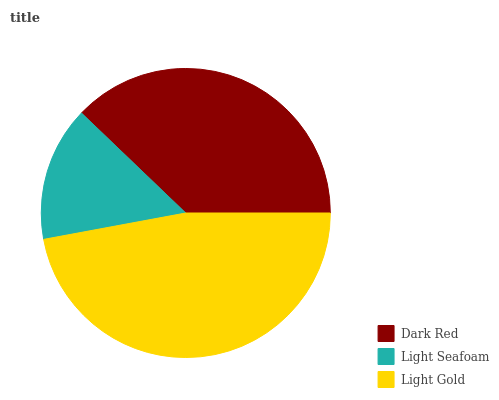Is Light Seafoam the minimum?
Answer yes or no. Yes. Is Light Gold the maximum?
Answer yes or no. Yes. Is Light Gold the minimum?
Answer yes or no. No. Is Light Seafoam the maximum?
Answer yes or no. No. Is Light Gold greater than Light Seafoam?
Answer yes or no. Yes. Is Light Seafoam less than Light Gold?
Answer yes or no. Yes. Is Light Seafoam greater than Light Gold?
Answer yes or no. No. Is Light Gold less than Light Seafoam?
Answer yes or no. No. Is Dark Red the high median?
Answer yes or no. Yes. Is Dark Red the low median?
Answer yes or no. Yes. Is Light Gold the high median?
Answer yes or no. No. Is Light Seafoam the low median?
Answer yes or no. No. 